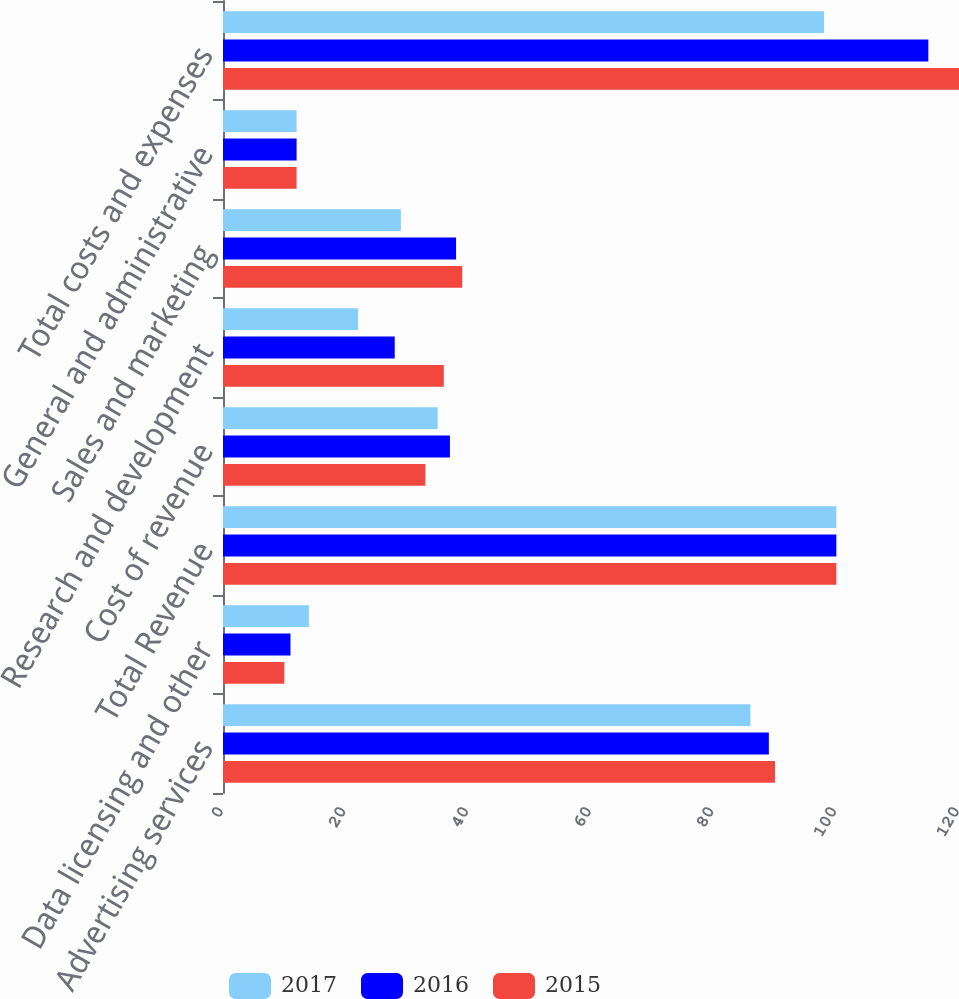Convert chart to OTSL. <chart><loc_0><loc_0><loc_500><loc_500><stacked_bar_chart><ecel><fcel>Advertising services<fcel>Data licensing and other<fcel>Total Revenue<fcel>Cost of revenue<fcel>Research and development<fcel>Sales and marketing<fcel>General and administrative<fcel>Total costs and expenses<nl><fcel>2017<fcel>86<fcel>14<fcel>100<fcel>35<fcel>22<fcel>29<fcel>12<fcel>98<nl><fcel>2016<fcel>89<fcel>11<fcel>100<fcel>37<fcel>28<fcel>38<fcel>12<fcel>115<nl><fcel>2015<fcel>90<fcel>10<fcel>100<fcel>33<fcel>36<fcel>39<fcel>12<fcel>120<nl></chart> 